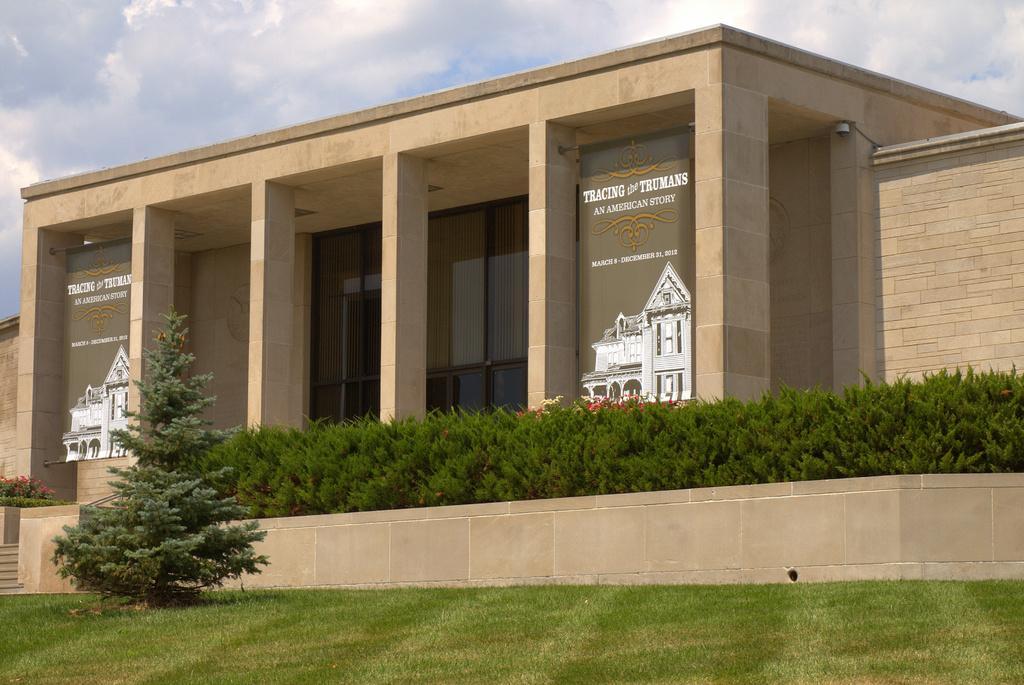Can you describe this image briefly? In this picture I can see the grass in front and in the middle of this picture, I can see a tree, few plants and few flowers. In the background I can see a building and I see 2 banners on which there is something written and I can see pictures of buildings on it and I can also see the walls on the both sides of this image. On the top of this picture I can see the cloudy sky. 